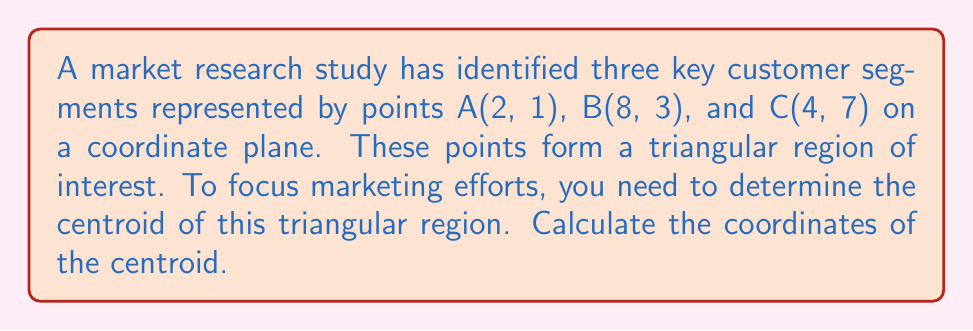Show me your answer to this math problem. To find the centroid of a triangular region, we follow these steps:

1. Recall the formula for the centroid of a triangle:
   The centroid coordinates $(x_c, y_c)$ are given by:
   $$x_c = \frac{x_1 + x_2 + x_3}{3}$$
   $$y_c = \frac{y_1 + y_2 + y_3}{3}$$
   where $(x_1, y_1)$, $(x_2, y_2)$, and $(x_3, y_3)$ are the coordinates of the triangle's vertices.

2. Identify the coordinates of the three vertices:
   A(2, 1), B(8, 3), C(4, 7)

3. Calculate the x-coordinate of the centroid:
   $$x_c = \frac{x_A + x_B + x_C}{3} = \frac{2 + 8 + 4}{3} = \frac{14}{3} \approx 4.67$$

4. Calculate the y-coordinate of the centroid:
   $$y_c = \frac{y_A + y_B + y_C}{3} = \frac{1 + 3 + 7}{3} = \frac{11}{3} \approx 3.67$$

5. Combine the results to get the centroid coordinates:
   $(\frac{14}{3}, \frac{11}{3})$ or approximately (4.67, 3.67)

[asy]
unitsize(1cm);
pair A = (2,1);
pair B = (8,3);
pair C = (4,7);
pair centroid = (14/3, 11/3);

draw(A--B--C--cycle);
dot(A); dot(B); dot(C); dot(centroid, red);

label("A", A, SW);
label("B", B, SE);
label("C", C, N);
label("Centroid", centroid, NE);

xaxis(0,9,arrow=Arrow);
yaxis(0,8,arrow=Arrow);
[/asy]
Answer: $(\frac{14}{3}, \frac{11}{3})$ 